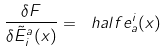<formula> <loc_0><loc_0><loc_500><loc_500>\frac { \delta F } { \delta \tilde { E } ^ { a } _ { i } ( x ) } = \ h a l f e ^ { i } _ { a } ( x )</formula> 